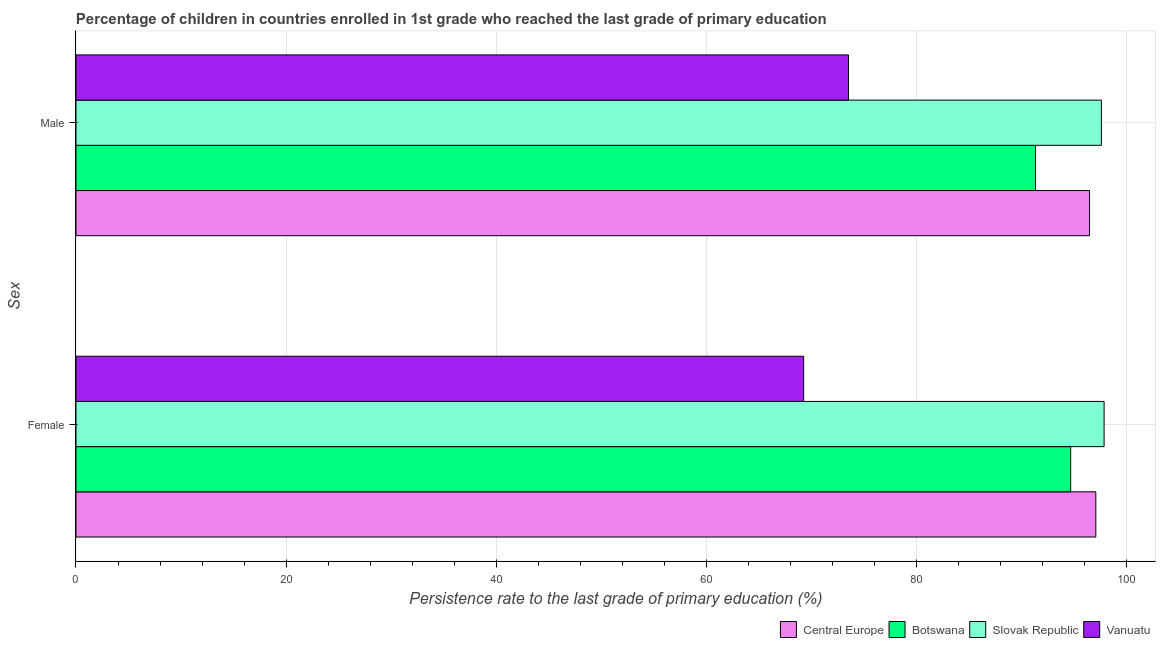How many groups of bars are there?
Give a very brief answer. 2. Are the number of bars per tick equal to the number of legend labels?
Provide a succinct answer. Yes. Are the number of bars on each tick of the Y-axis equal?
Offer a very short reply. Yes. How many bars are there on the 2nd tick from the top?
Give a very brief answer. 4. What is the label of the 2nd group of bars from the top?
Keep it short and to the point. Female. What is the persistence rate of female students in Botswana?
Keep it short and to the point. 94.68. Across all countries, what is the maximum persistence rate of male students?
Provide a short and direct response. 97.6. Across all countries, what is the minimum persistence rate of male students?
Provide a succinct answer. 73.53. In which country was the persistence rate of male students maximum?
Your answer should be compact. Slovak Republic. In which country was the persistence rate of male students minimum?
Give a very brief answer. Vanuatu. What is the total persistence rate of male students in the graph?
Provide a succinct answer. 358.94. What is the difference between the persistence rate of female students in Botswana and that in Slovak Republic?
Provide a short and direct response. -3.18. What is the difference between the persistence rate of female students in Central Europe and the persistence rate of male students in Botswana?
Give a very brief answer. 5.74. What is the average persistence rate of male students per country?
Your response must be concise. 89.73. What is the difference between the persistence rate of male students and persistence rate of female students in Vanuatu?
Make the answer very short. 4.27. In how many countries, is the persistence rate of male students greater than 8 %?
Make the answer very short. 4. What is the ratio of the persistence rate of male students in Slovak Republic to that in Vanuatu?
Ensure brevity in your answer.  1.33. Is the persistence rate of female students in Central Europe less than that in Vanuatu?
Give a very brief answer. No. In how many countries, is the persistence rate of male students greater than the average persistence rate of male students taken over all countries?
Your answer should be very brief. 3. What does the 1st bar from the top in Male represents?
Give a very brief answer. Vanuatu. What does the 4th bar from the bottom in Female represents?
Ensure brevity in your answer.  Vanuatu. How many bars are there?
Your answer should be very brief. 8. Are all the bars in the graph horizontal?
Provide a short and direct response. Yes. How many countries are there in the graph?
Provide a succinct answer. 4. What is the difference between two consecutive major ticks on the X-axis?
Your answer should be very brief. 20. Are the values on the major ticks of X-axis written in scientific E-notation?
Your answer should be very brief. No. Does the graph contain any zero values?
Your answer should be very brief. No. Where does the legend appear in the graph?
Give a very brief answer. Bottom right. How many legend labels are there?
Your response must be concise. 4. What is the title of the graph?
Provide a succinct answer. Percentage of children in countries enrolled in 1st grade who reached the last grade of primary education. Does "Monaco" appear as one of the legend labels in the graph?
Your response must be concise. No. What is the label or title of the X-axis?
Ensure brevity in your answer.  Persistence rate to the last grade of primary education (%). What is the label or title of the Y-axis?
Your response must be concise. Sex. What is the Persistence rate to the last grade of primary education (%) in Central Europe in Female?
Your answer should be very brief. 97.07. What is the Persistence rate to the last grade of primary education (%) in Botswana in Female?
Provide a succinct answer. 94.68. What is the Persistence rate to the last grade of primary education (%) of Slovak Republic in Female?
Make the answer very short. 97.86. What is the Persistence rate to the last grade of primary education (%) in Vanuatu in Female?
Your answer should be very brief. 69.26. What is the Persistence rate to the last grade of primary education (%) in Central Europe in Male?
Your answer should be very brief. 96.48. What is the Persistence rate to the last grade of primary education (%) in Botswana in Male?
Ensure brevity in your answer.  91.33. What is the Persistence rate to the last grade of primary education (%) in Slovak Republic in Male?
Your answer should be very brief. 97.6. What is the Persistence rate to the last grade of primary education (%) of Vanuatu in Male?
Your answer should be very brief. 73.53. Across all Sex, what is the maximum Persistence rate to the last grade of primary education (%) of Central Europe?
Make the answer very short. 97.07. Across all Sex, what is the maximum Persistence rate to the last grade of primary education (%) of Botswana?
Keep it short and to the point. 94.68. Across all Sex, what is the maximum Persistence rate to the last grade of primary education (%) in Slovak Republic?
Your answer should be very brief. 97.86. Across all Sex, what is the maximum Persistence rate to the last grade of primary education (%) in Vanuatu?
Provide a short and direct response. 73.53. Across all Sex, what is the minimum Persistence rate to the last grade of primary education (%) of Central Europe?
Your response must be concise. 96.48. Across all Sex, what is the minimum Persistence rate to the last grade of primary education (%) in Botswana?
Provide a short and direct response. 91.33. Across all Sex, what is the minimum Persistence rate to the last grade of primary education (%) in Slovak Republic?
Give a very brief answer. 97.6. Across all Sex, what is the minimum Persistence rate to the last grade of primary education (%) in Vanuatu?
Your answer should be compact. 69.26. What is the total Persistence rate to the last grade of primary education (%) of Central Europe in the graph?
Provide a short and direct response. 193.55. What is the total Persistence rate to the last grade of primary education (%) in Botswana in the graph?
Keep it short and to the point. 186.01. What is the total Persistence rate to the last grade of primary education (%) of Slovak Republic in the graph?
Make the answer very short. 195.46. What is the total Persistence rate to the last grade of primary education (%) of Vanuatu in the graph?
Offer a very short reply. 142.79. What is the difference between the Persistence rate to the last grade of primary education (%) of Central Europe in Female and that in Male?
Your response must be concise. 0.59. What is the difference between the Persistence rate to the last grade of primary education (%) in Botswana in Female and that in Male?
Provide a succinct answer. 3.34. What is the difference between the Persistence rate to the last grade of primary education (%) in Slovak Republic in Female and that in Male?
Ensure brevity in your answer.  0.26. What is the difference between the Persistence rate to the last grade of primary education (%) in Vanuatu in Female and that in Male?
Provide a succinct answer. -4.27. What is the difference between the Persistence rate to the last grade of primary education (%) in Central Europe in Female and the Persistence rate to the last grade of primary education (%) in Botswana in Male?
Provide a short and direct response. 5.74. What is the difference between the Persistence rate to the last grade of primary education (%) of Central Europe in Female and the Persistence rate to the last grade of primary education (%) of Slovak Republic in Male?
Offer a very short reply. -0.53. What is the difference between the Persistence rate to the last grade of primary education (%) of Central Europe in Female and the Persistence rate to the last grade of primary education (%) of Vanuatu in Male?
Offer a terse response. 23.54. What is the difference between the Persistence rate to the last grade of primary education (%) in Botswana in Female and the Persistence rate to the last grade of primary education (%) in Slovak Republic in Male?
Make the answer very short. -2.92. What is the difference between the Persistence rate to the last grade of primary education (%) in Botswana in Female and the Persistence rate to the last grade of primary education (%) in Vanuatu in Male?
Make the answer very short. 21.15. What is the difference between the Persistence rate to the last grade of primary education (%) in Slovak Republic in Female and the Persistence rate to the last grade of primary education (%) in Vanuatu in Male?
Offer a terse response. 24.33. What is the average Persistence rate to the last grade of primary education (%) in Central Europe per Sex?
Provide a succinct answer. 96.77. What is the average Persistence rate to the last grade of primary education (%) of Botswana per Sex?
Your response must be concise. 93. What is the average Persistence rate to the last grade of primary education (%) of Slovak Republic per Sex?
Your response must be concise. 97.73. What is the average Persistence rate to the last grade of primary education (%) of Vanuatu per Sex?
Your answer should be very brief. 71.39. What is the difference between the Persistence rate to the last grade of primary education (%) of Central Europe and Persistence rate to the last grade of primary education (%) of Botswana in Female?
Offer a terse response. 2.39. What is the difference between the Persistence rate to the last grade of primary education (%) in Central Europe and Persistence rate to the last grade of primary education (%) in Slovak Republic in Female?
Make the answer very short. -0.79. What is the difference between the Persistence rate to the last grade of primary education (%) of Central Europe and Persistence rate to the last grade of primary education (%) of Vanuatu in Female?
Provide a succinct answer. 27.81. What is the difference between the Persistence rate to the last grade of primary education (%) of Botswana and Persistence rate to the last grade of primary education (%) of Slovak Republic in Female?
Your answer should be compact. -3.18. What is the difference between the Persistence rate to the last grade of primary education (%) of Botswana and Persistence rate to the last grade of primary education (%) of Vanuatu in Female?
Provide a short and direct response. 25.41. What is the difference between the Persistence rate to the last grade of primary education (%) in Slovak Republic and Persistence rate to the last grade of primary education (%) in Vanuatu in Female?
Provide a short and direct response. 28.6. What is the difference between the Persistence rate to the last grade of primary education (%) in Central Europe and Persistence rate to the last grade of primary education (%) in Botswana in Male?
Your response must be concise. 5.14. What is the difference between the Persistence rate to the last grade of primary education (%) in Central Europe and Persistence rate to the last grade of primary education (%) in Slovak Republic in Male?
Make the answer very short. -1.13. What is the difference between the Persistence rate to the last grade of primary education (%) in Central Europe and Persistence rate to the last grade of primary education (%) in Vanuatu in Male?
Your answer should be very brief. 22.95. What is the difference between the Persistence rate to the last grade of primary education (%) of Botswana and Persistence rate to the last grade of primary education (%) of Slovak Republic in Male?
Ensure brevity in your answer.  -6.27. What is the difference between the Persistence rate to the last grade of primary education (%) in Botswana and Persistence rate to the last grade of primary education (%) in Vanuatu in Male?
Offer a terse response. 17.81. What is the difference between the Persistence rate to the last grade of primary education (%) in Slovak Republic and Persistence rate to the last grade of primary education (%) in Vanuatu in Male?
Give a very brief answer. 24.07. What is the ratio of the Persistence rate to the last grade of primary education (%) of Botswana in Female to that in Male?
Your answer should be compact. 1.04. What is the ratio of the Persistence rate to the last grade of primary education (%) of Vanuatu in Female to that in Male?
Keep it short and to the point. 0.94. What is the difference between the highest and the second highest Persistence rate to the last grade of primary education (%) of Central Europe?
Your response must be concise. 0.59. What is the difference between the highest and the second highest Persistence rate to the last grade of primary education (%) in Botswana?
Offer a very short reply. 3.34. What is the difference between the highest and the second highest Persistence rate to the last grade of primary education (%) of Slovak Republic?
Keep it short and to the point. 0.26. What is the difference between the highest and the second highest Persistence rate to the last grade of primary education (%) of Vanuatu?
Give a very brief answer. 4.27. What is the difference between the highest and the lowest Persistence rate to the last grade of primary education (%) in Central Europe?
Ensure brevity in your answer.  0.59. What is the difference between the highest and the lowest Persistence rate to the last grade of primary education (%) of Botswana?
Your answer should be compact. 3.34. What is the difference between the highest and the lowest Persistence rate to the last grade of primary education (%) of Slovak Republic?
Offer a terse response. 0.26. What is the difference between the highest and the lowest Persistence rate to the last grade of primary education (%) in Vanuatu?
Your response must be concise. 4.27. 